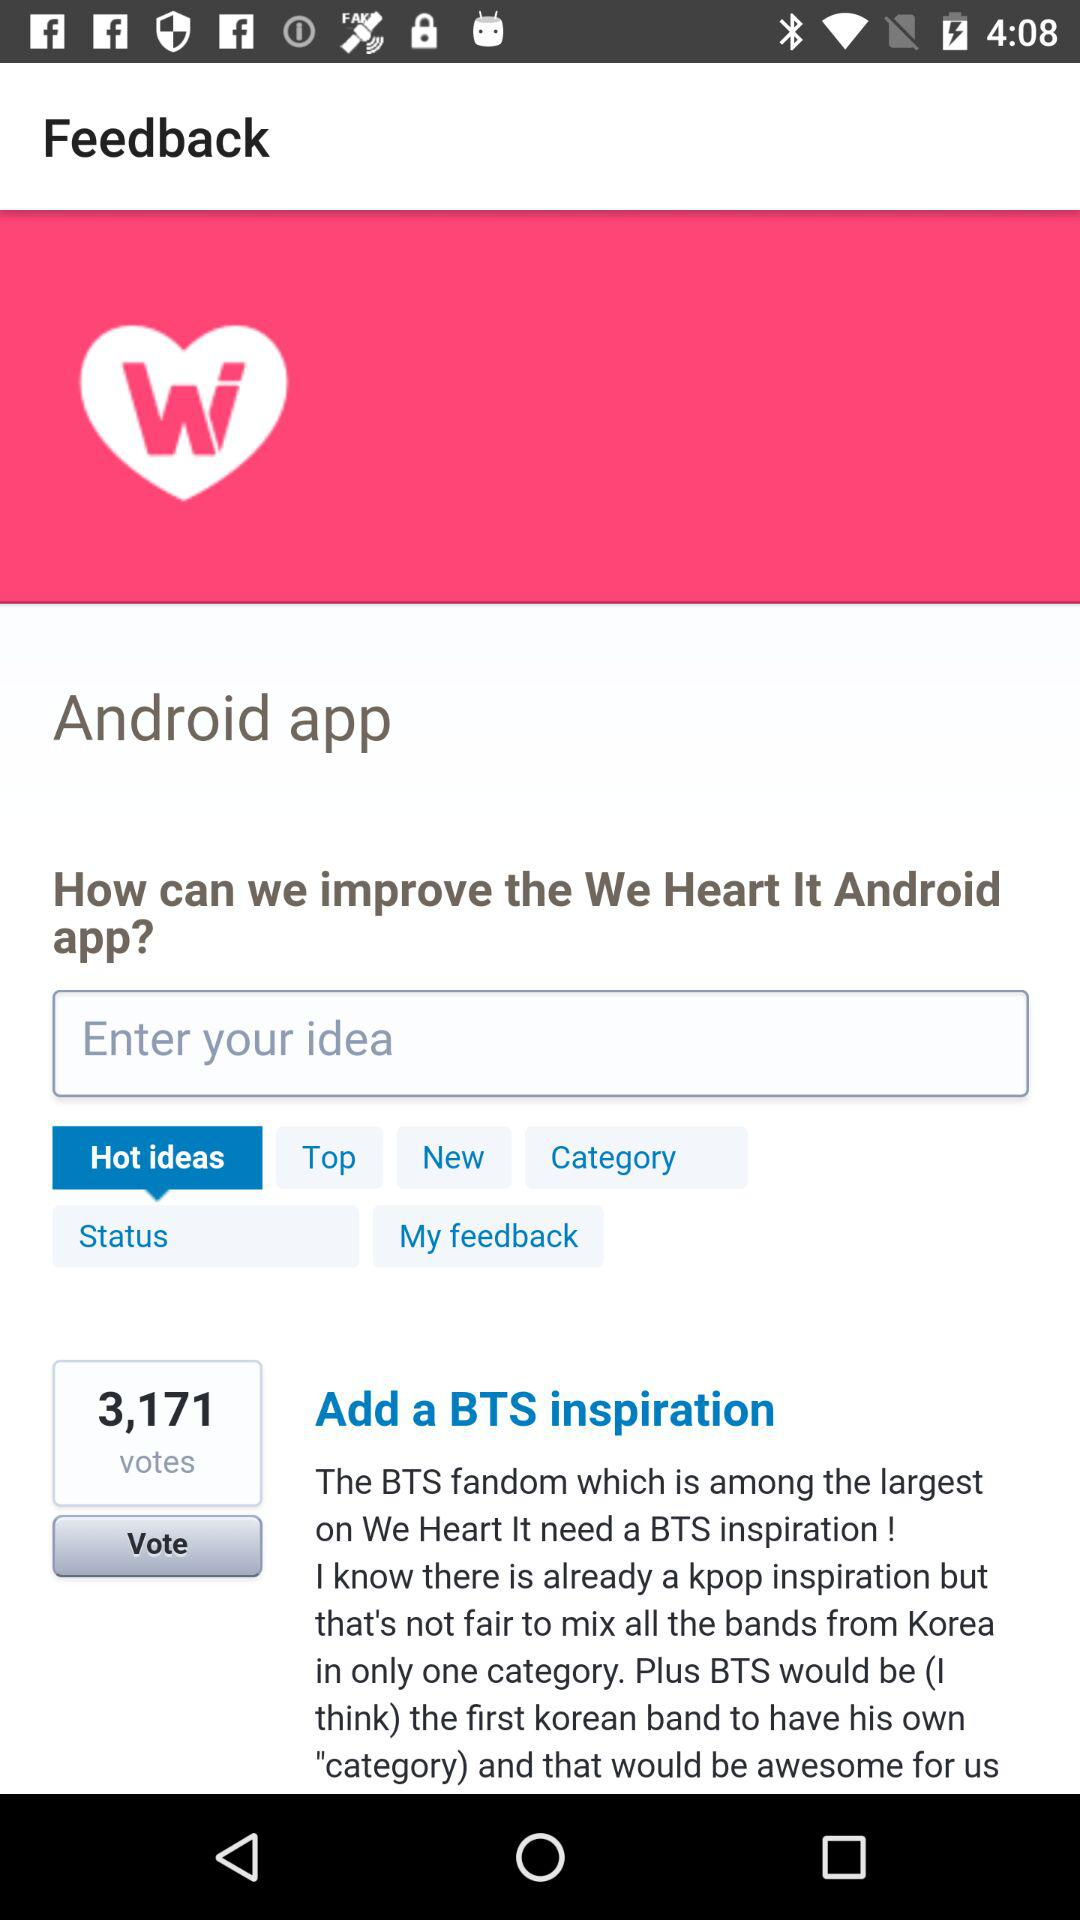Which option has been selected? The selected option is "Hot ideas". 